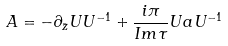Convert formula to latex. <formula><loc_0><loc_0><loc_500><loc_500>A = - \partial _ { \bar { z } } U U ^ { - 1 } + { \frac { i \pi } { I m \tau } } U a U ^ { - 1 }</formula> 